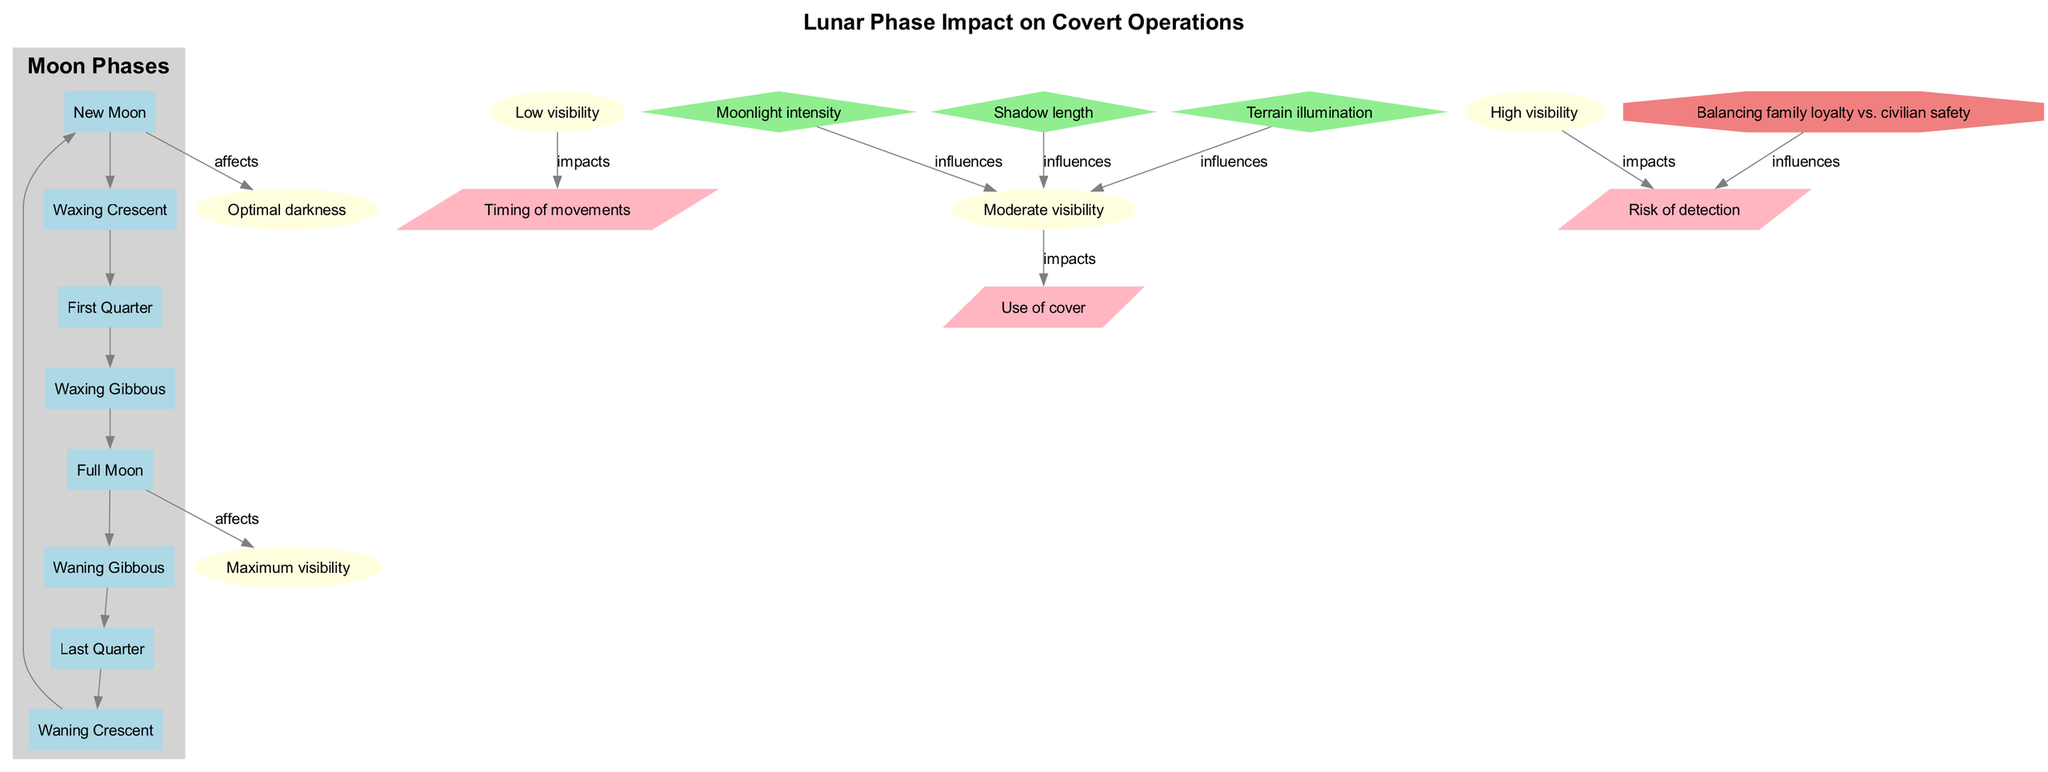What are the moon phases listed in the diagram? The diagram includes the following moon phases: New Moon, Waxing Crescent, First Quarter, Waxing Gibbous, Full Moon, Waning Gibbous, Last Quarter, and Waning Crescent. This is extracted from the section labeled "Moon Phases."
Answer: New Moon, Waxing Crescent, First Quarter, Waxing Gibbous, Full Moon, Waning Gibbous, Last Quarter, Waning Crescent How many visibility levels are there? The diagram presents five different visibility levels: Optimal darkness, Low visibility, Moderate visibility, High visibility, and Maximum visibility. These are outlined under the section titled "Visibility Levels."
Answer: 5 Which visibility level is affected by the New Moon? The diagram indicates that the New Moon affects the Optimal darkness visibility level. The edge labeled "affects" connects the New Moon node to the Optimal darkness node.
Answer: Optimal darkness What influences the Moderate visibility level? The diagram shows that three key factors: Moonlight intensity, Shadow length, and Terrain illumination influence the Moderate visibility level. Following the arrows from the key factors leads to the Moderate visibility node, indicating their impact.
Answer: Moonlight intensity, Shadow length, Terrain illumination Which operational consideration is impacted by Low visibility? According to the diagram, the Low visibility level impacts the Use of cover operational consideration. This is indicated by an edge showing the connection between Low visibility and Use of cover.
Answer: Use of cover What factor influences the ethical dilemma? The ethical dilemma is influenced by the operational consideration related to the Risk of detection. The diagram shows an edge leading from the ethical dilemma node to the Risk of detection node, asserting this influence.
Answer: Risk of detection During which moon phase is visibility at its maximum? The diagram states that visibility is at its maximum during the Full Moon phase, as indicated by the edge from the Full Moon node to the Maximum visibility node.
Answer: Full Moon Which phases lead to high visibility? The Waxing Gibbous and Full Moon phases lead to high visibility according to the connections in the diagram. Arrows from these phases connect to the High visibility node, showing their contributions to that visibility level.
Answer: Waxing Gibbous, Full Moon 